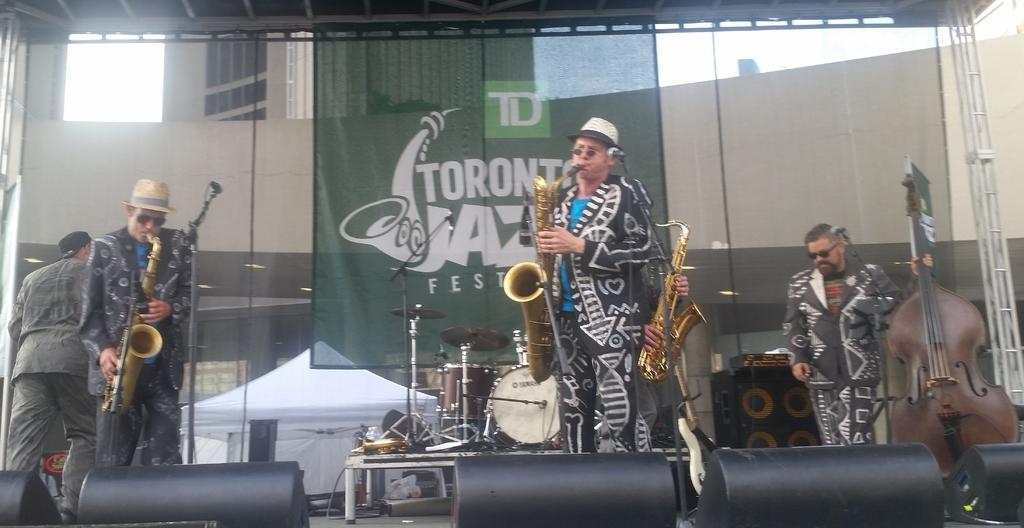How would you summarize this image in a sentence or two? In this image we can see a group of people standing on the stage holding the musical instruments. We can also see some objects on a table, speaker boxes and the miles with the stands beside them. We can also see a tent, a banner with some text on it, the metal poles, a building with windows, some ceiling lights and the sky. 